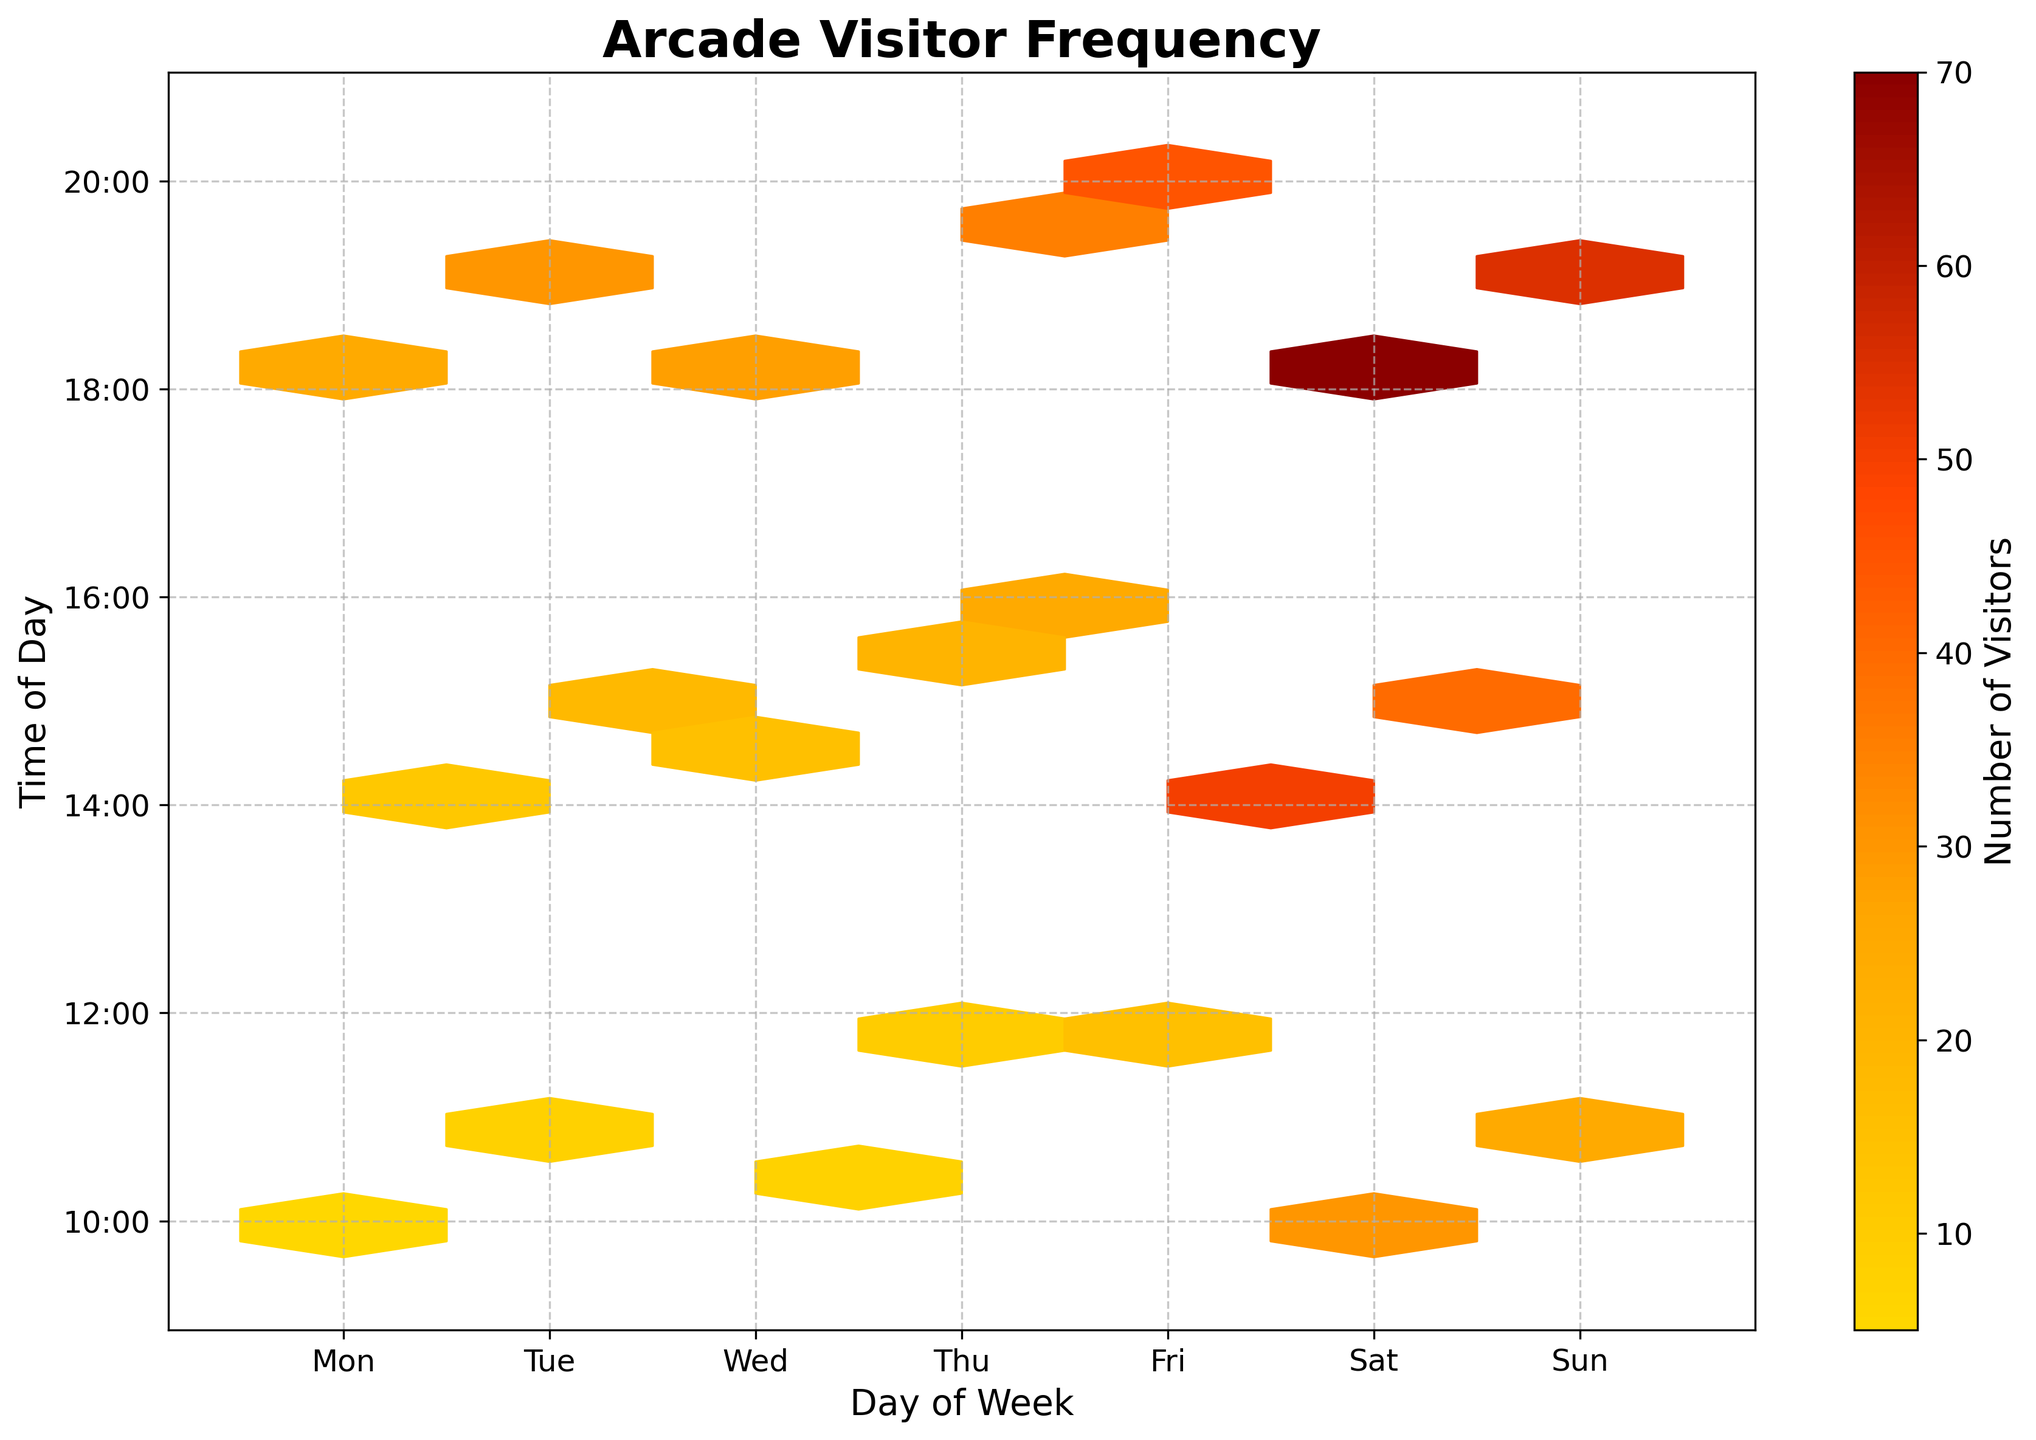What's the title of the figure? The title is clearly displayed at the top of the figure. It reads 'Arcade Visitor Frequency'.
Answer: Arcade Visitor Frequency On which day and time did the arcade have the highest number of visitors? Looking at the color intensity in the hexbin plot, the darkest region represents the highest number of visitors. This region is around Saturday at 18:00.
Answer: Saturday, 18:00 How are the days of the week represented on the X-axis? The X-axis labels are the days of the week starting from Monday and ending on Sunday. The days are labeled as 'Mon', 'Tue', 'Wed', 'Thu', 'Fri', 'Sat', 'Sun'.
Answer: Mon, Tue, Wed, Thu, Fri, Sat, Sun What time intervals are represented on the Y-axis? The Y-axis labels represent the time intervals from '10:00' to '20:00'. Specific times labeled are 10:00, 12:00, 14:00, 16:00, 18:00, and 20:00.
Answer: 10:00, 12:00, 14:00, 16:00, 18:00, 20:00 Comparing different days, which day has the maximum concentration of visitors between 14:00 and 16:00? Observing the region between the 14:00 and 16:00 time interval on the Y-axis and comparing the darkest hexagons on different days, Saturday shows the highest concentration of visitors.
Answer: Saturday What's the color indicating the least number of visitors? The color bar located next to the plot indicates that light yellow represents the least number of visitors.
Answer: Light yellow Which weekday has the peak number of visitors earliest in the day? By looking at the darkest hexes closest to the earliest hours on each weekday, Sunday has a peak at 11:00.
Answer: Sunday What's the overall trend of visitors from weekday to weekend? The hexbin plot visual shows that darker colors, indicating more visitors, start appearing mostly on weekends (particularly Saturday and Sunday) as you move to the right of the X-axis towards the weekend.
Answer: Increasing toward the weekend What's the range of visitor numbers according to the color bar? The color bar on the right side of the plot shows the range from light yellow (lowest number) to dark red (highest number). Exact numbers are not available without the figure, but it ranges from the lowest number to the highest represented on the plot.
Answer: A range from low to high number of visitors If you add up the number of hexagons with the highest concentration, which days contribute the most? To determine this, we have to observe the darkest areas across all days. The majority of darkest hexagons (representing the highest concentration) appear on Saturday and Sunday, indicating that these days contribute the most.
Answer: Saturday and Sunday 